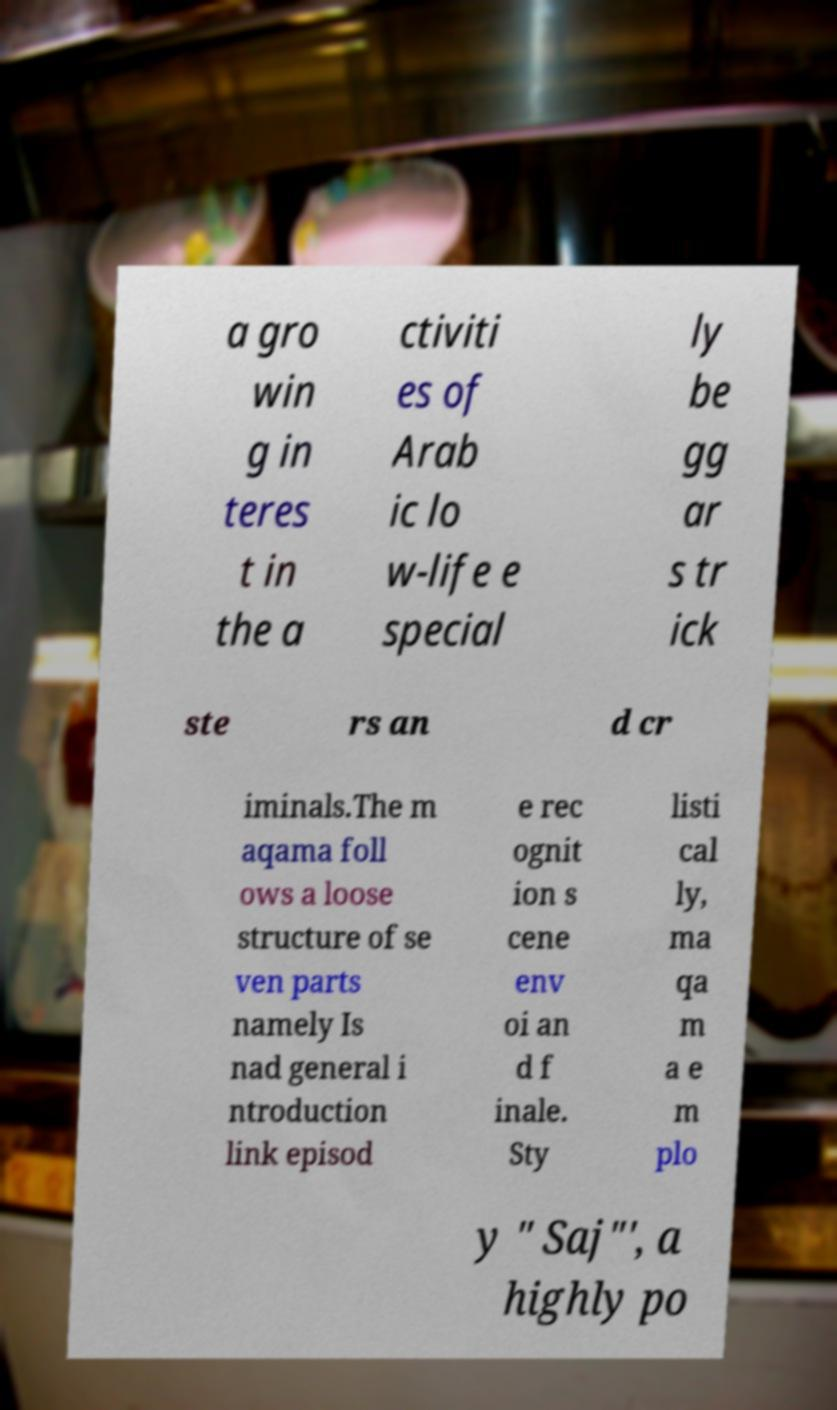There's text embedded in this image that I need extracted. Can you transcribe it verbatim? a gro win g in teres t in the a ctiviti es of Arab ic lo w-life e special ly be gg ar s tr ick ste rs an d cr iminals.The m aqama foll ows a loose structure of se ven parts namely Is nad general i ntroduction link episod e rec ognit ion s cene env oi an d f inale. Sty listi cal ly, ma qa m a e m plo y " Saj"', a highly po 